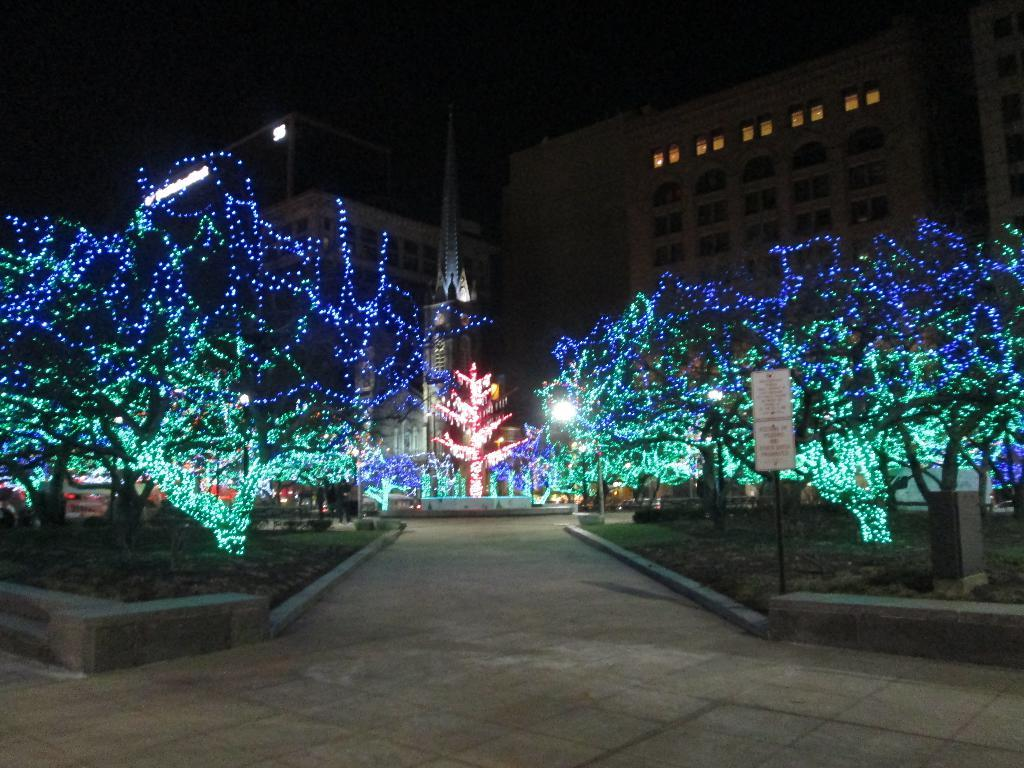What type of structures are present in the image? There are buildings in the image. What feature can be seen on the buildings? There are windows visible in the image. What object is present in the image that might be used for displaying information? There is a board in the image. What vertical object is present in the image? There is a pole in the image. What type of decoration can be seen on the trees in the image? There are trees with colorful lights in the image. How would you describe the overall lighting in the image? The image is dark. Where is the mailbox located in the image? There is no mailbox present in the image. What type of jar is visible on the board in the image? There is no jar present on the board in the image. 